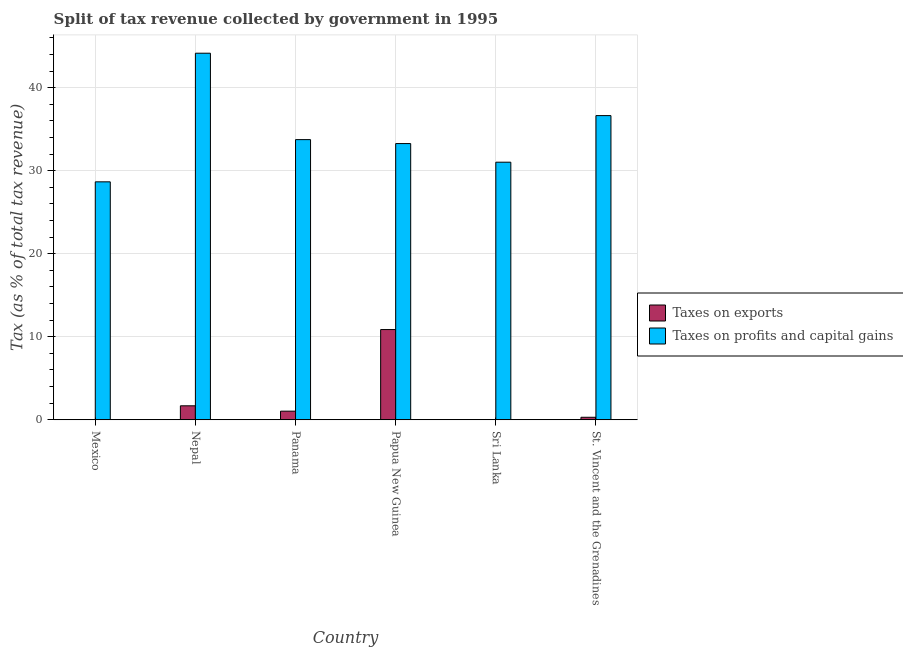How many groups of bars are there?
Ensure brevity in your answer.  6. Are the number of bars per tick equal to the number of legend labels?
Offer a very short reply. Yes. What is the label of the 6th group of bars from the left?
Keep it short and to the point. St. Vincent and the Grenadines. What is the percentage of revenue obtained from taxes on profits and capital gains in Mexico?
Your response must be concise. 28.66. Across all countries, what is the maximum percentage of revenue obtained from taxes on exports?
Offer a very short reply. 10.87. Across all countries, what is the minimum percentage of revenue obtained from taxes on exports?
Offer a very short reply. 0.01. In which country was the percentage of revenue obtained from taxes on profits and capital gains maximum?
Your answer should be compact. Nepal. In which country was the percentage of revenue obtained from taxes on profits and capital gains minimum?
Give a very brief answer. Mexico. What is the total percentage of revenue obtained from taxes on exports in the graph?
Offer a very short reply. 13.94. What is the difference between the percentage of revenue obtained from taxes on profits and capital gains in Mexico and that in Panama?
Your response must be concise. -5.09. What is the difference between the percentage of revenue obtained from taxes on exports in Sri Lanka and the percentage of revenue obtained from taxes on profits and capital gains in Papua New Guinea?
Offer a very short reply. -33.27. What is the average percentage of revenue obtained from taxes on profits and capital gains per country?
Offer a terse response. 34.59. What is the difference between the percentage of revenue obtained from taxes on profits and capital gains and percentage of revenue obtained from taxes on exports in St. Vincent and the Grenadines?
Keep it short and to the point. 36.34. What is the ratio of the percentage of revenue obtained from taxes on profits and capital gains in Panama to that in Sri Lanka?
Offer a very short reply. 1.09. Is the difference between the percentage of revenue obtained from taxes on profits and capital gains in Nepal and St. Vincent and the Grenadines greater than the difference between the percentage of revenue obtained from taxes on exports in Nepal and St. Vincent and the Grenadines?
Provide a succinct answer. Yes. What is the difference between the highest and the second highest percentage of revenue obtained from taxes on exports?
Offer a terse response. 9.19. What is the difference between the highest and the lowest percentage of revenue obtained from taxes on profits and capital gains?
Keep it short and to the point. 15.5. What does the 2nd bar from the left in Nepal represents?
Keep it short and to the point. Taxes on profits and capital gains. What does the 1st bar from the right in Papua New Guinea represents?
Provide a short and direct response. Taxes on profits and capital gains. Are the values on the major ticks of Y-axis written in scientific E-notation?
Your answer should be compact. No. Does the graph contain grids?
Offer a terse response. Yes. Where does the legend appear in the graph?
Provide a short and direct response. Center right. How are the legend labels stacked?
Provide a short and direct response. Vertical. What is the title of the graph?
Offer a terse response. Split of tax revenue collected by government in 1995. Does "Underweight" appear as one of the legend labels in the graph?
Keep it short and to the point. No. What is the label or title of the Y-axis?
Your answer should be very brief. Tax (as % of total tax revenue). What is the Tax (as % of total tax revenue) of Taxes on exports in Mexico?
Give a very brief answer. 0.03. What is the Tax (as % of total tax revenue) of Taxes on profits and capital gains in Mexico?
Your answer should be compact. 28.66. What is the Tax (as % of total tax revenue) in Taxes on exports in Nepal?
Make the answer very short. 1.69. What is the Tax (as % of total tax revenue) in Taxes on profits and capital gains in Nepal?
Your answer should be very brief. 44.16. What is the Tax (as % of total tax revenue) of Taxes on exports in Panama?
Your answer should be very brief. 1.04. What is the Tax (as % of total tax revenue) of Taxes on profits and capital gains in Panama?
Your response must be concise. 33.75. What is the Tax (as % of total tax revenue) in Taxes on exports in Papua New Guinea?
Offer a terse response. 10.87. What is the Tax (as % of total tax revenue) in Taxes on profits and capital gains in Papua New Guinea?
Provide a short and direct response. 33.27. What is the Tax (as % of total tax revenue) of Taxes on exports in Sri Lanka?
Your answer should be very brief. 0.01. What is the Tax (as % of total tax revenue) in Taxes on profits and capital gains in Sri Lanka?
Offer a very short reply. 31.03. What is the Tax (as % of total tax revenue) of Taxes on exports in St. Vincent and the Grenadines?
Provide a short and direct response. 0.3. What is the Tax (as % of total tax revenue) of Taxes on profits and capital gains in St. Vincent and the Grenadines?
Keep it short and to the point. 36.64. Across all countries, what is the maximum Tax (as % of total tax revenue) in Taxes on exports?
Offer a terse response. 10.87. Across all countries, what is the maximum Tax (as % of total tax revenue) in Taxes on profits and capital gains?
Ensure brevity in your answer.  44.16. Across all countries, what is the minimum Tax (as % of total tax revenue) of Taxes on exports?
Keep it short and to the point. 0.01. Across all countries, what is the minimum Tax (as % of total tax revenue) of Taxes on profits and capital gains?
Your answer should be very brief. 28.66. What is the total Tax (as % of total tax revenue) of Taxes on exports in the graph?
Your response must be concise. 13.94. What is the total Tax (as % of total tax revenue) of Taxes on profits and capital gains in the graph?
Ensure brevity in your answer.  207.53. What is the difference between the Tax (as % of total tax revenue) of Taxes on exports in Mexico and that in Nepal?
Make the answer very short. -1.65. What is the difference between the Tax (as % of total tax revenue) of Taxes on profits and capital gains in Mexico and that in Nepal?
Provide a short and direct response. -15.5. What is the difference between the Tax (as % of total tax revenue) in Taxes on exports in Mexico and that in Panama?
Your answer should be very brief. -1.01. What is the difference between the Tax (as % of total tax revenue) of Taxes on profits and capital gains in Mexico and that in Panama?
Provide a succinct answer. -5.09. What is the difference between the Tax (as % of total tax revenue) of Taxes on exports in Mexico and that in Papua New Guinea?
Offer a very short reply. -10.84. What is the difference between the Tax (as % of total tax revenue) in Taxes on profits and capital gains in Mexico and that in Papua New Guinea?
Your answer should be very brief. -4.61. What is the difference between the Tax (as % of total tax revenue) in Taxes on exports in Mexico and that in Sri Lanka?
Give a very brief answer. 0.03. What is the difference between the Tax (as % of total tax revenue) of Taxes on profits and capital gains in Mexico and that in Sri Lanka?
Make the answer very short. -2.37. What is the difference between the Tax (as % of total tax revenue) of Taxes on exports in Mexico and that in St. Vincent and the Grenadines?
Your answer should be very brief. -0.27. What is the difference between the Tax (as % of total tax revenue) of Taxes on profits and capital gains in Mexico and that in St. Vincent and the Grenadines?
Give a very brief answer. -7.98. What is the difference between the Tax (as % of total tax revenue) in Taxes on exports in Nepal and that in Panama?
Provide a short and direct response. 0.64. What is the difference between the Tax (as % of total tax revenue) in Taxes on profits and capital gains in Nepal and that in Panama?
Give a very brief answer. 10.41. What is the difference between the Tax (as % of total tax revenue) of Taxes on exports in Nepal and that in Papua New Guinea?
Provide a succinct answer. -9.19. What is the difference between the Tax (as % of total tax revenue) in Taxes on profits and capital gains in Nepal and that in Papua New Guinea?
Your answer should be very brief. 10.89. What is the difference between the Tax (as % of total tax revenue) of Taxes on exports in Nepal and that in Sri Lanka?
Make the answer very short. 1.68. What is the difference between the Tax (as % of total tax revenue) in Taxes on profits and capital gains in Nepal and that in Sri Lanka?
Your answer should be very brief. 13.13. What is the difference between the Tax (as % of total tax revenue) in Taxes on exports in Nepal and that in St. Vincent and the Grenadines?
Make the answer very short. 1.38. What is the difference between the Tax (as % of total tax revenue) in Taxes on profits and capital gains in Nepal and that in St. Vincent and the Grenadines?
Provide a short and direct response. 7.52. What is the difference between the Tax (as % of total tax revenue) in Taxes on exports in Panama and that in Papua New Guinea?
Make the answer very short. -9.83. What is the difference between the Tax (as % of total tax revenue) of Taxes on profits and capital gains in Panama and that in Papua New Guinea?
Your answer should be very brief. 0.48. What is the difference between the Tax (as % of total tax revenue) of Taxes on exports in Panama and that in Sri Lanka?
Keep it short and to the point. 1.03. What is the difference between the Tax (as % of total tax revenue) in Taxes on profits and capital gains in Panama and that in Sri Lanka?
Your response must be concise. 2.72. What is the difference between the Tax (as % of total tax revenue) of Taxes on exports in Panama and that in St. Vincent and the Grenadines?
Provide a short and direct response. 0.74. What is the difference between the Tax (as % of total tax revenue) of Taxes on profits and capital gains in Panama and that in St. Vincent and the Grenadines?
Your answer should be very brief. -2.89. What is the difference between the Tax (as % of total tax revenue) of Taxes on exports in Papua New Guinea and that in Sri Lanka?
Make the answer very short. 10.86. What is the difference between the Tax (as % of total tax revenue) of Taxes on profits and capital gains in Papua New Guinea and that in Sri Lanka?
Provide a short and direct response. 2.24. What is the difference between the Tax (as % of total tax revenue) of Taxes on exports in Papua New Guinea and that in St. Vincent and the Grenadines?
Your answer should be very brief. 10.57. What is the difference between the Tax (as % of total tax revenue) in Taxes on profits and capital gains in Papua New Guinea and that in St. Vincent and the Grenadines?
Provide a short and direct response. -3.37. What is the difference between the Tax (as % of total tax revenue) in Taxes on exports in Sri Lanka and that in St. Vincent and the Grenadines?
Offer a terse response. -0.3. What is the difference between the Tax (as % of total tax revenue) of Taxes on profits and capital gains in Sri Lanka and that in St. Vincent and the Grenadines?
Provide a short and direct response. -5.61. What is the difference between the Tax (as % of total tax revenue) in Taxes on exports in Mexico and the Tax (as % of total tax revenue) in Taxes on profits and capital gains in Nepal?
Offer a terse response. -44.13. What is the difference between the Tax (as % of total tax revenue) in Taxes on exports in Mexico and the Tax (as % of total tax revenue) in Taxes on profits and capital gains in Panama?
Your response must be concise. -33.72. What is the difference between the Tax (as % of total tax revenue) of Taxes on exports in Mexico and the Tax (as % of total tax revenue) of Taxes on profits and capital gains in Papua New Guinea?
Ensure brevity in your answer.  -33.24. What is the difference between the Tax (as % of total tax revenue) in Taxes on exports in Mexico and the Tax (as % of total tax revenue) in Taxes on profits and capital gains in Sri Lanka?
Keep it short and to the point. -31. What is the difference between the Tax (as % of total tax revenue) of Taxes on exports in Mexico and the Tax (as % of total tax revenue) of Taxes on profits and capital gains in St. Vincent and the Grenadines?
Give a very brief answer. -36.61. What is the difference between the Tax (as % of total tax revenue) in Taxes on exports in Nepal and the Tax (as % of total tax revenue) in Taxes on profits and capital gains in Panama?
Your answer should be very brief. -32.07. What is the difference between the Tax (as % of total tax revenue) of Taxes on exports in Nepal and the Tax (as % of total tax revenue) of Taxes on profits and capital gains in Papua New Guinea?
Offer a terse response. -31.59. What is the difference between the Tax (as % of total tax revenue) of Taxes on exports in Nepal and the Tax (as % of total tax revenue) of Taxes on profits and capital gains in Sri Lanka?
Give a very brief answer. -29.35. What is the difference between the Tax (as % of total tax revenue) of Taxes on exports in Nepal and the Tax (as % of total tax revenue) of Taxes on profits and capital gains in St. Vincent and the Grenadines?
Give a very brief answer. -34.96. What is the difference between the Tax (as % of total tax revenue) of Taxes on exports in Panama and the Tax (as % of total tax revenue) of Taxes on profits and capital gains in Papua New Guinea?
Your response must be concise. -32.23. What is the difference between the Tax (as % of total tax revenue) of Taxes on exports in Panama and the Tax (as % of total tax revenue) of Taxes on profits and capital gains in Sri Lanka?
Your answer should be compact. -29.99. What is the difference between the Tax (as % of total tax revenue) in Taxes on exports in Panama and the Tax (as % of total tax revenue) in Taxes on profits and capital gains in St. Vincent and the Grenadines?
Ensure brevity in your answer.  -35.6. What is the difference between the Tax (as % of total tax revenue) of Taxes on exports in Papua New Guinea and the Tax (as % of total tax revenue) of Taxes on profits and capital gains in Sri Lanka?
Ensure brevity in your answer.  -20.16. What is the difference between the Tax (as % of total tax revenue) in Taxes on exports in Papua New Guinea and the Tax (as % of total tax revenue) in Taxes on profits and capital gains in St. Vincent and the Grenadines?
Ensure brevity in your answer.  -25.77. What is the difference between the Tax (as % of total tax revenue) of Taxes on exports in Sri Lanka and the Tax (as % of total tax revenue) of Taxes on profits and capital gains in St. Vincent and the Grenadines?
Make the answer very short. -36.64. What is the average Tax (as % of total tax revenue) of Taxes on exports per country?
Make the answer very short. 2.32. What is the average Tax (as % of total tax revenue) of Taxes on profits and capital gains per country?
Ensure brevity in your answer.  34.59. What is the difference between the Tax (as % of total tax revenue) of Taxes on exports and Tax (as % of total tax revenue) of Taxes on profits and capital gains in Mexico?
Offer a terse response. -28.63. What is the difference between the Tax (as % of total tax revenue) of Taxes on exports and Tax (as % of total tax revenue) of Taxes on profits and capital gains in Nepal?
Provide a succinct answer. -42.47. What is the difference between the Tax (as % of total tax revenue) in Taxes on exports and Tax (as % of total tax revenue) in Taxes on profits and capital gains in Panama?
Keep it short and to the point. -32.71. What is the difference between the Tax (as % of total tax revenue) of Taxes on exports and Tax (as % of total tax revenue) of Taxes on profits and capital gains in Papua New Guinea?
Your answer should be very brief. -22.4. What is the difference between the Tax (as % of total tax revenue) of Taxes on exports and Tax (as % of total tax revenue) of Taxes on profits and capital gains in Sri Lanka?
Make the answer very short. -31.02. What is the difference between the Tax (as % of total tax revenue) of Taxes on exports and Tax (as % of total tax revenue) of Taxes on profits and capital gains in St. Vincent and the Grenadines?
Ensure brevity in your answer.  -36.34. What is the ratio of the Tax (as % of total tax revenue) of Taxes on exports in Mexico to that in Nepal?
Offer a very short reply. 0.02. What is the ratio of the Tax (as % of total tax revenue) of Taxes on profits and capital gains in Mexico to that in Nepal?
Your response must be concise. 0.65. What is the ratio of the Tax (as % of total tax revenue) of Taxes on exports in Mexico to that in Panama?
Offer a terse response. 0.03. What is the ratio of the Tax (as % of total tax revenue) of Taxes on profits and capital gains in Mexico to that in Panama?
Your answer should be very brief. 0.85. What is the ratio of the Tax (as % of total tax revenue) in Taxes on exports in Mexico to that in Papua New Guinea?
Make the answer very short. 0. What is the ratio of the Tax (as % of total tax revenue) of Taxes on profits and capital gains in Mexico to that in Papua New Guinea?
Give a very brief answer. 0.86. What is the ratio of the Tax (as % of total tax revenue) in Taxes on exports in Mexico to that in Sri Lanka?
Ensure brevity in your answer.  4.76. What is the ratio of the Tax (as % of total tax revenue) of Taxes on profits and capital gains in Mexico to that in Sri Lanka?
Keep it short and to the point. 0.92. What is the ratio of the Tax (as % of total tax revenue) in Taxes on exports in Mexico to that in St. Vincent and the Grenadines?
Provide a short and direct response. 0.11. What is the ratio of the Tax (as % of total tax revenue) of Taxes on profits and capital gains in Mexico to that in St. Vincent and the Grenadines?
Offer a very short reply. 0.78. What is the ratio of the Tax (as % of total tax revenue) of Taxes on exports in Nepal to that in Panama?
Your answer should be compact. 1.62. What is the ratio of the Tax (as % of total tax revenue) of Taxes on profits and capital gains in Nepal to that in Panama?
Provide a succinct answer. 1.31. What is the ratio of the Tax (as % of total tax revenue) of Taxes on exports in Nepal to that in Papua New Guinea?
Your answer should be very brief. 0.16. What is the ratio of the Tax (as % of total tax revenue) of Taxes on profits and capital gains in Nepal to that in Papua New Guinea?
Your answer should be compact. 1.33. What is the ratio of the Tax (as % of total tax revenue) in Taxes on exports in Nepal to that in Sri Lanka?
Give a very brief answer. 249.8. What is the ratio of the Tax (as % of total tax revenue) in Taxes on profits and capital gains in Nepal to that in Sri Lanka?
Offer a terse response. 1.42. What is the ratio of the Tax (as % of total tax revenue) of Taxes on exports in Nepal to that in St. Vincent and the Grenadines?
Make the answer very short. 5.53. What is the ratio of the Tax (as % of total tax revenue) in Taxes on profits and capital gains in Nepal to that in St. Vincent and the Grenadines?
Provide a short and direct response. 1.21. What is the ratio of the Tax (as % of total tax revenue) of Taxes on exports in Panama to that in Papua New Guinea?
Make the answer very short. 0.1. What is the ratio of the Tax (as % of total tax revenue) of Taxes on profits and capital gains in Panama to that in Papua New Guinea?
Your answer should be compact. 1.01. What is the ratio of the Tax (as % of total tax revenue) in Taxes on exports in Panama to that in Sri Lanka?
Offer a very short reply. 154.26. What is the ratio of the Tax (as % of total tax revenue) of Taxes on profits and capital gains in Panama to that in Sri Lanka?
Offer a very short reply. 1.09. What is the ratio of the Tax (as % of total tax revenue) in Taxes on exports in Panama to that in St. Vincent and the Grenadines?
Keep it short and to the point. 3.41. What is the ratio of the Tax (as % of total tax revenue) in Taxes on profits and capital gains in Panama to that in St. Vincent and the Grenadines?
Offer a very short reply. 0.92. What is the ratio of the Tax (as % of total tax revenue) in Taxes on exports in Papua New Guinea to that in Sri Lanka?
Your response must be concise. 1610.89. What is the ratio of the Tax (as % of total tax revenue) of Taxes on profits and capital gains in Papua New Guinea to that in Sri Lanka?
Ensure brevity in your answer.  1.07. What is the ratio of the Tax (as % of total tax revenue) in Taxes on exports in Papua New Guinea to that in St. Vincent and the Grenadines?
Your response must be concise. 35.66. What is the ratio of the Tax (as % of total tax revenue) of Taxes on profits and capital gains in Papua New Guinea to that in St. Vincent and the Grenadines?
Provide a short and direct response. 0.91. What is the ratio of the Tax (as % of total tax revenue) in Taxes on exports in Sri Lanka to that in St. Vincent and the Grenadines?
Offer a very short reply. 0.02. What is the ratio of the Tax (as % of total tax revenue) in Taxes on profits and capital gains in Sri Lanka to that in St. Vincent and the Grenadines?
Ensure brevity in your answer.  0.85. What is the difference between the highest and the second highest Tax (as % of total tax revenue) of Taxes on exports?
Provide a succinct answer. 9.19. What is the difference between the highest and the second highest Tax (as % of total tax revenue) in Taxes on profits and capital gains?
Provide a short and direct response. 7.52. What is the difference between the highest and the lowest Tax (as % of total tax revenue) of Taxes on exports?
Provide a succinct answer. 10.86. What is the difference between the highest and the lowest Tax (as % of total tax revenue) in Taxes on profits and capital gains?
Provide a succinct answer. 15.5. 